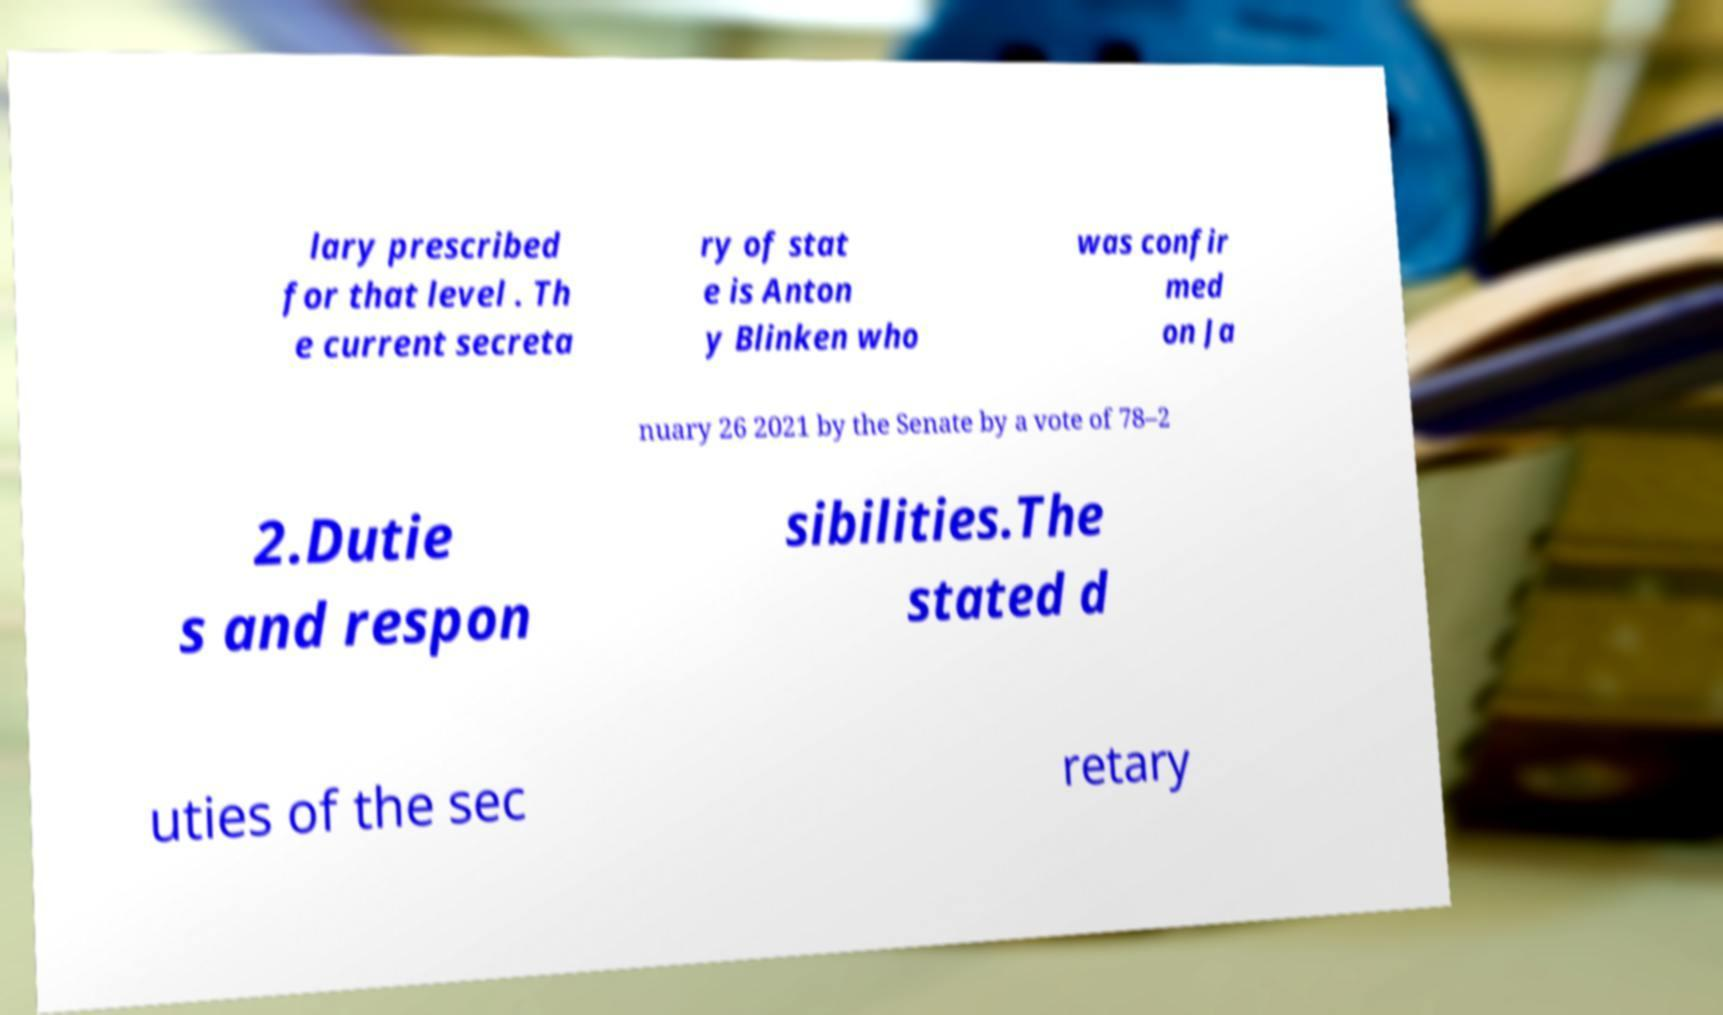Could you assist in decoding the text presented in this image and type it out clearly? lary prescribed for that level . Th e current secreta ry of stat e is Anton y Blinken who was confir med on Ja nuary 26 2021 by the Senate by a vote of 78–2 2.Dutie s and respon sibilities.The stated d uties of the sec retary 